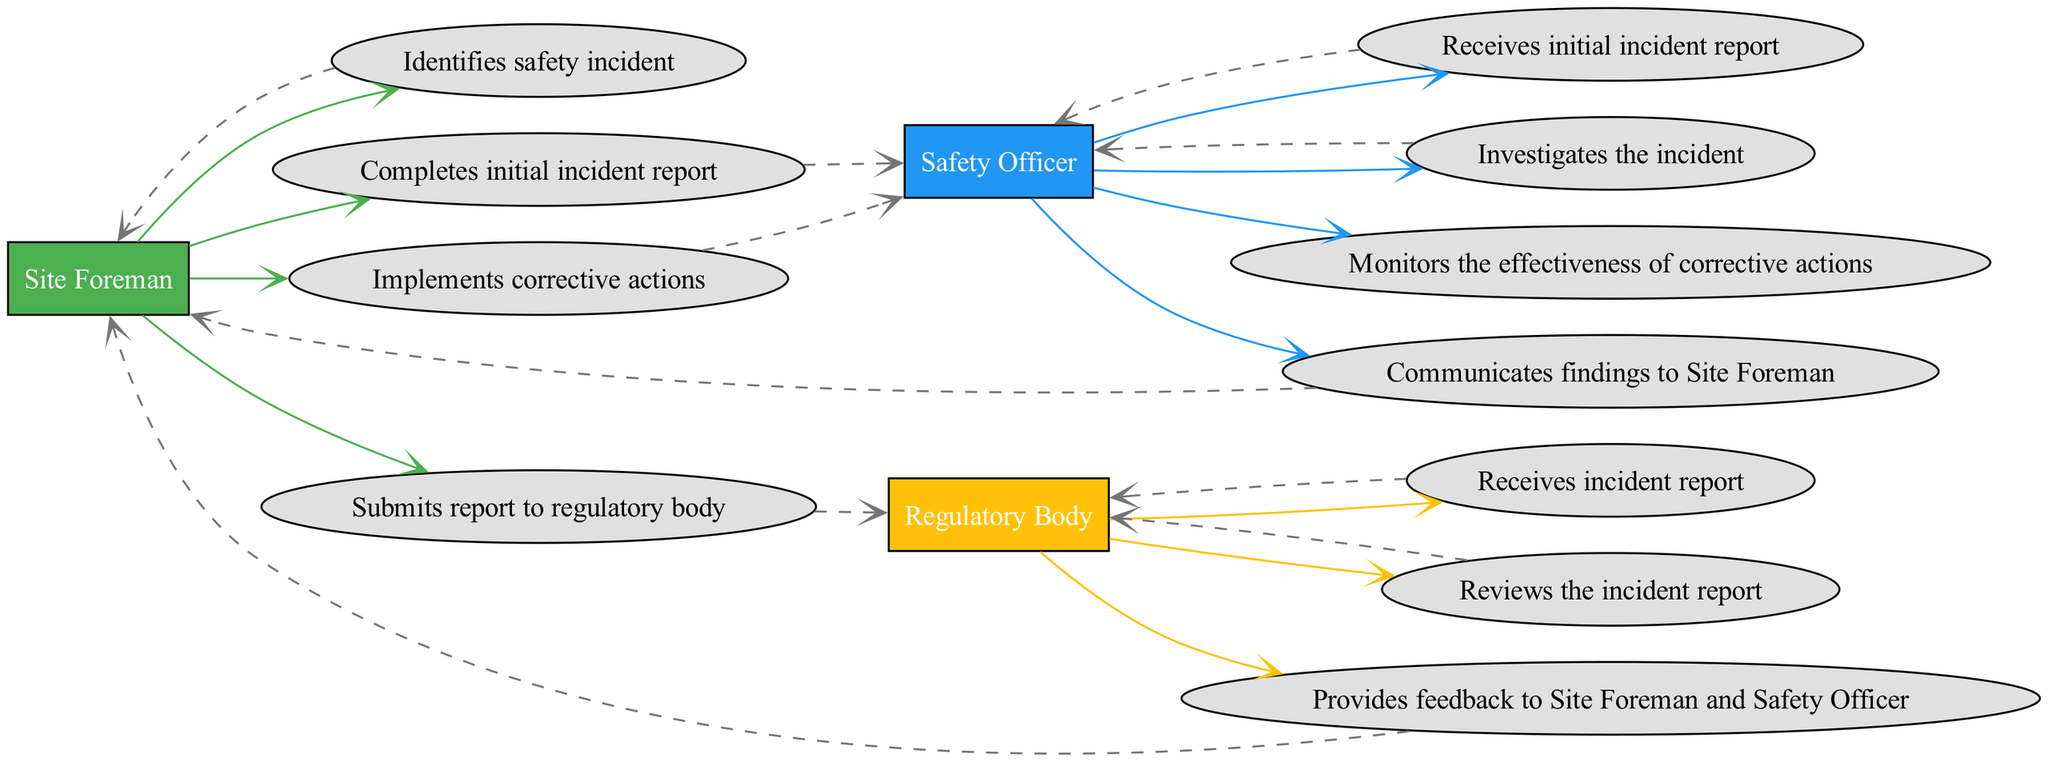What is the first action taken in the process? The first action in the process is taken by the Site Foreman, who identifies the safety incident.
Answer: Identifies safety incident Who receives the initial incident report? The initial incident report is received by the Safety Officer after the Site Foreman completes it.
Answer: Safety Officer How many actors are involved in this diagram? There are three actors involved in the diagram: Site Foreman, Safety Officer, and Regulatory Body.
Answer: Three Which action follows the investigation of the incident? After investigating the incident, the Safety Officer communicates their findings to the Site Foreman.
Answer: Communicates findings to Site Foreman What action does the Site Foreman take after completing the report? After completing the report, the Site Foreman submits it to the regulatory body.
Answer: Submits report to regulatory body Which actor monitors the effectiveness of corrective actions? The Safety Officer is responsible for monitoring the effectiveness of the corrective actions that are implemented.
Answer: Safety Officer What type of relationship exists between the Safety Officer and the Regulatory Body? The relationship is one of communication, where the Regulatory Body reviews the incident report and provides feedback to both the Site Foreman and Safety Officer.
Answer: Communication How many actions are performed by the Safety Officer in the diagram? The Safety Officer performs four actions in total throughout the process.
Answer: Four What is the last action taken before the corrective actions are implemented? The last action taken before implementing corrective actions is receiving feedback from the Regulatory Body.
Answer: Provides feedback to Site Foreman and Safety Officer 